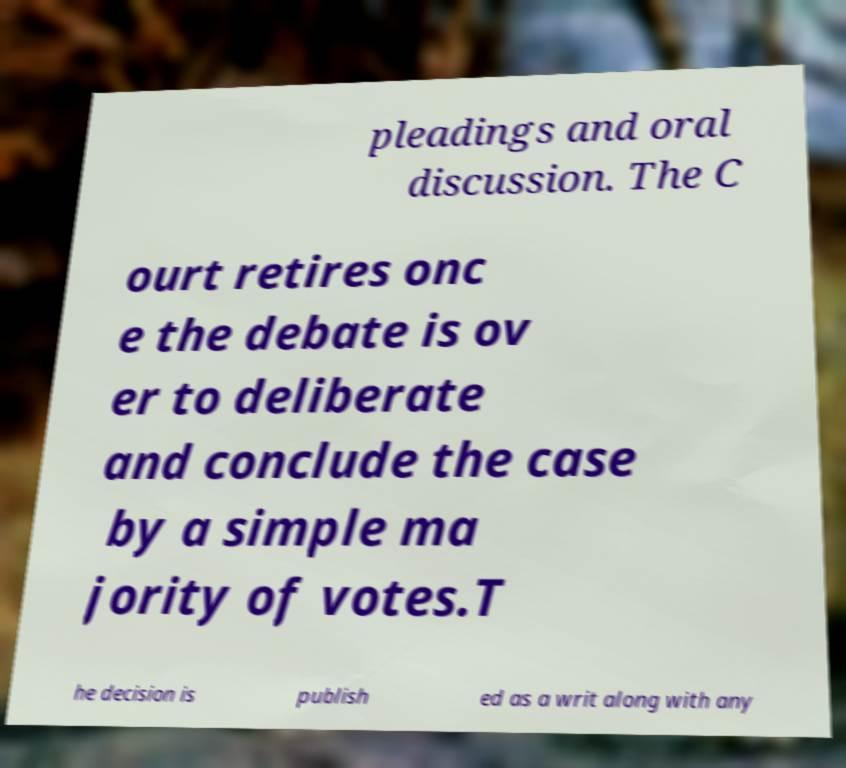Please read and relay the text visible in this image. What does it say? pleadings and oral discussion. The C ourt retires onc e the debate is ov er to deliberate and conclude the case by a simple ma jority of votes.T he decision is publish ed as a writ along with any 